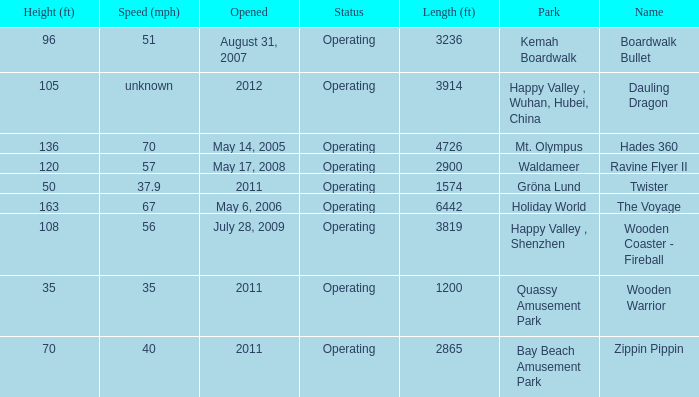Help me parse the entirety of this table. {'header': ['Height (ft)', 'Speed (mph)', 'Opened', 'Status', 'Length (ft)', 'Park', 'Name'], 'rows': [['96', '51', 'August 31, 2007', 'Operating', '3236', 'Kemah Boardwalk', 'Boardwalk Bullet'], ['105', 'unknown', '2012', 'Operating', '3914', 'Happy Valley , Wuhan, Hubei, China', 'Dauling Dragon'], ['136', '70', 'May 14, 2005', 'Operating', '4726', 'Mt. Olympus', 'Hades 360'], ['120', '57', 'May 17, 2008', 'Operating', '2900', 'Waldameer', 'Ravine Flyer II'], ['50', '37.9', '2011', 'Operating', '1574', 'Gröna Lund', 'Twister'], ['163', '67', 'May 6, 2006', 'Operating', '6442', 'Holiday World', 'The Voyage'], ['108', '56', 'July 28, 2009', 'Operating', '3819', 'Happy Valley , Shenzhen', 'Wooden Coaster - Fireball'], ['35', '35', '2011', 'Operating', '1200', 'Quassy Amusement Park', 'Wooden Warrior'], ['70', '40', '2011', 'Operating', '2865', 'Bay Beach Amusement Park', 'Zippin Pippin']]} How many parks is Zippin Pippin located in 1.0. 